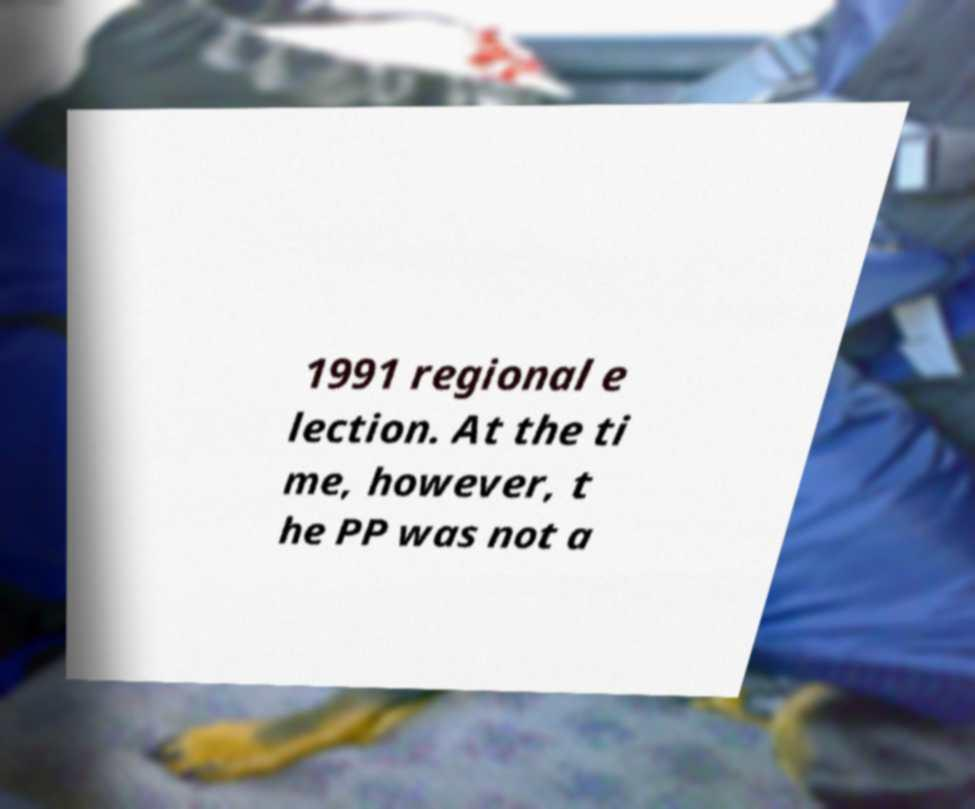There's text embedded in this image that I need extracted. Can you transcribe it verbatim? 1991 regional e lection. At the ti me, however, t he PP was not a 